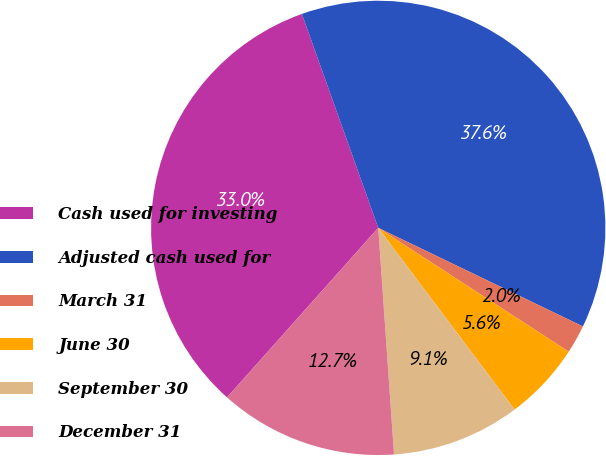Convert chart. <chart><loc_0><loc_0><loc_500><loc_500><pie_chart><fcel>Cash used for investing<fcel>Adjusted cash used for<fcel>March 31<fcel>June 30<fcel>September 30<fcel>December 31<nl><fcel>32.95%<fcel>37.6%<fcel>2.03%<fcel>5.58%<fcel>9.14%<fcel>12.7%<nl></chart> 